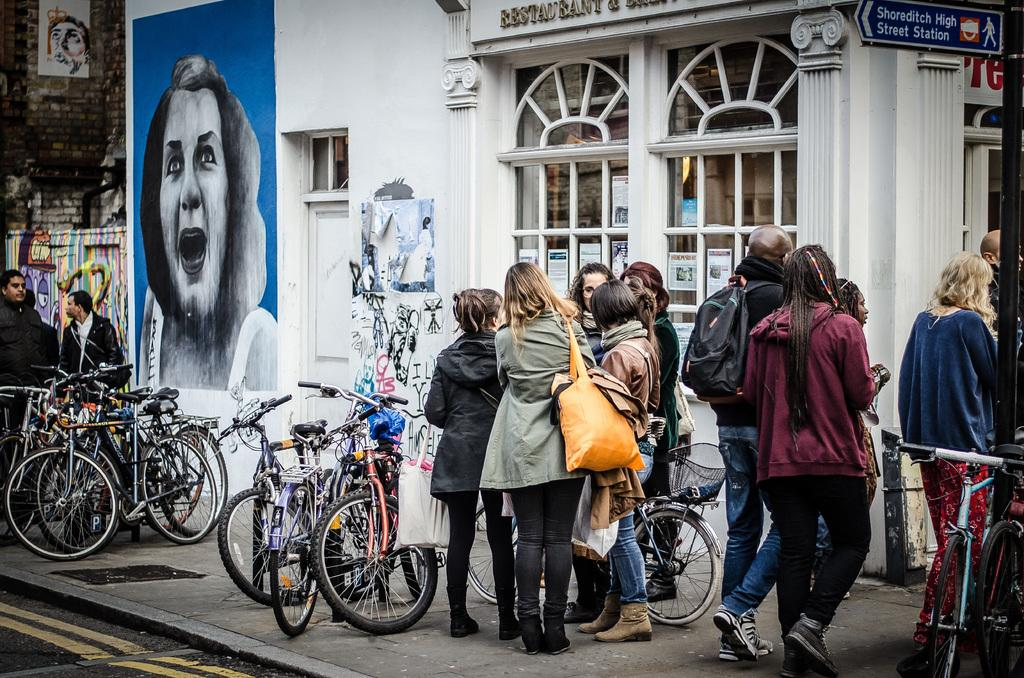What are the people in the image doing? The people in the image are standing on a footpath. What type of vehicles can be seen in the image? There are cycles in the image. What is visible in the background of the image? There is a building in the background of the image. Can you see any cobwebs on the cycles in the image? There is no mention of cobwebs in the image, so it cannot be determined if any are present. 